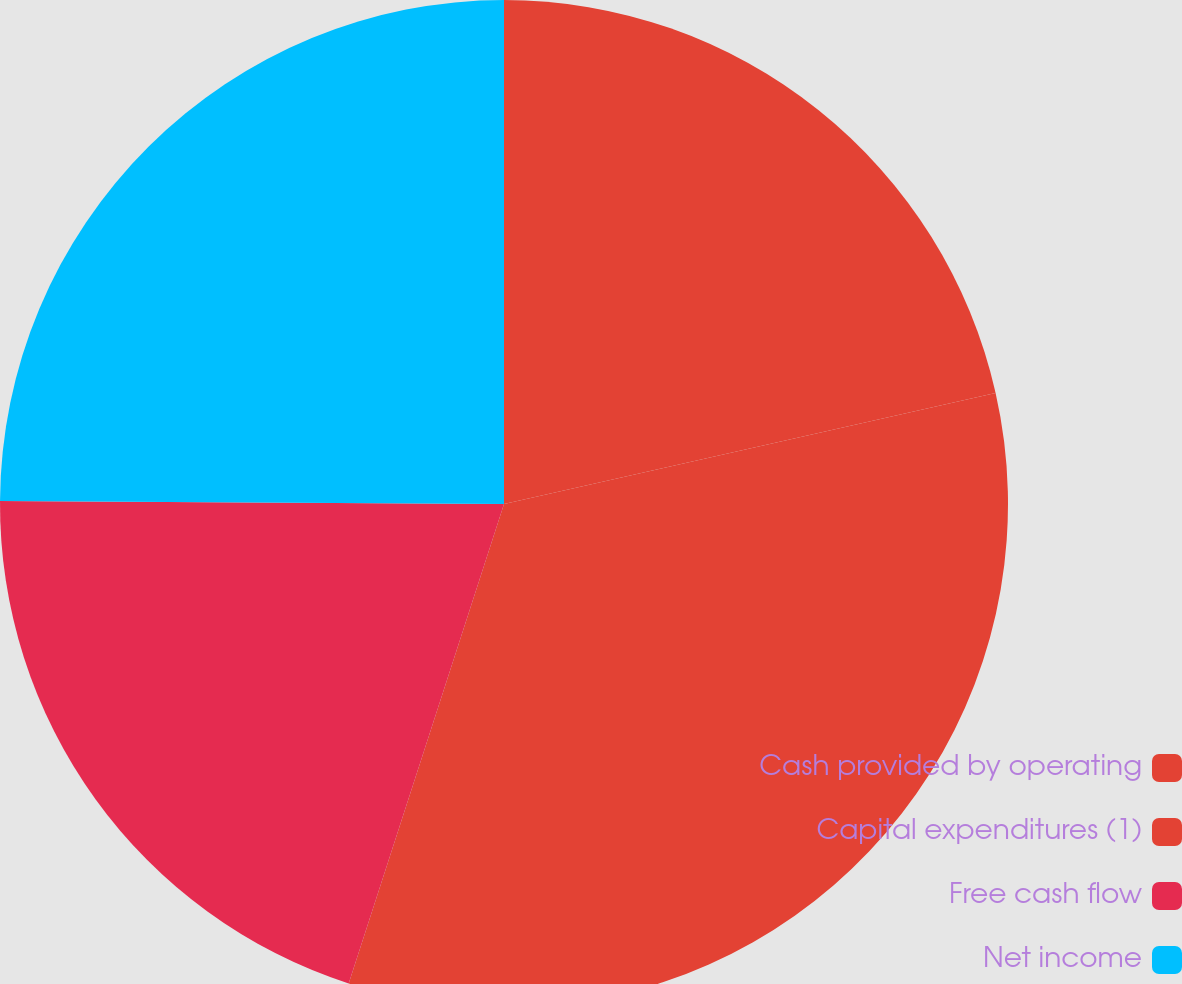Convert chart. <chart><loc_0><loc_0><loc_500><loc_500><pie_chart><fcel>Cash provided by operating<fcel>Capital expenditures (1)<fcel>Free cash flow<fcel>Net income<nl><fcel>21.46%<fcel>33.52%<fcel>20.11%<fcel>24.9%<nl></chart> 